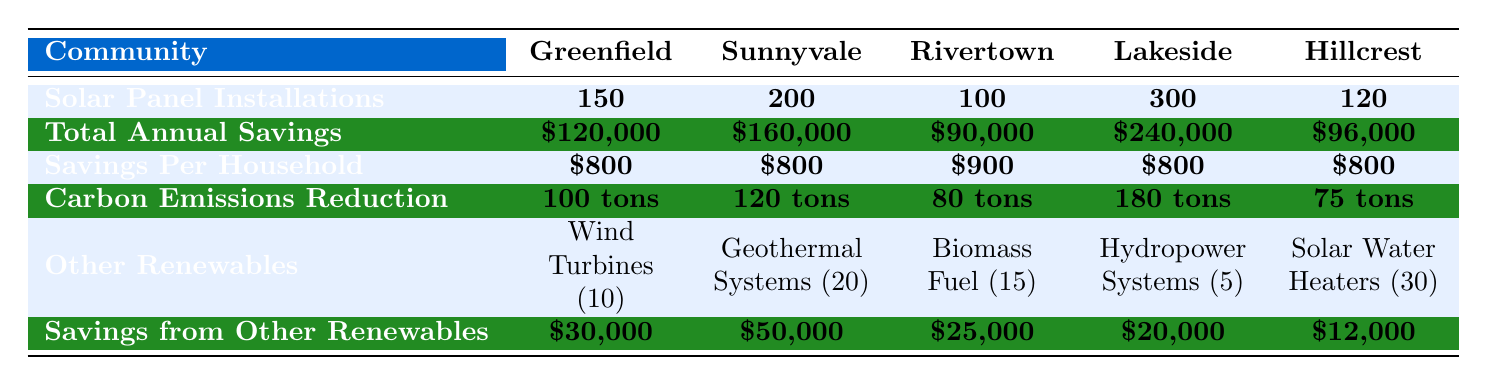What is the total annual savings for Lakeside? In the table, under the "Total Annual Savings" row for Lakeside, the value is listed as \$240,000.
Answer: \$240,000 How many solar panel installations were there in Sunnyvale? In the table, the row for "Solar Panel Installations" shows that Sunnyvale has 200 installations.
Answer: 200 Which community had the highest carbon emissions reduction? By comparing the "Carbon Emissions Reduction" values for each community, Lakeside has the highest at 180 tons.
Answer: Lakeside What is the average savings per household across all communities? The savings per household values are \$800 (Greenfield), \$800 (Sunnyvale), \$900 (Rivertown), \$800 (Lakeside), and \$800 (Hillcrest). Adding them gives \$800 + \$800 + \$900 + \$800 + \$800 = \$4100. Dividing by 5 communities gives \$4100 / 5 = \$820.
Answer: \$820 How much less total annual savings does Rivertown have compared to Lakeside? Rivertown has \$90,000 in total annual savings, while Lakeside has \$240,000. The difference is \$240,000 - \$90,000 = \$150,000.
Answer: \$150,000 Is it true that Hillcrest has more solar panel installations than both Greenfield and Rivertown? Hillcrest has 120 installations, while Greenfield has 150 and Rivertown has 100. Since 120 is not more than 150, the statement is false.
Answer: False What is the combined annual savings from other renewables in Greenfield and Rivertown? Greenfield has \$30,000 and Rivertown has \$25,000 from other renewables. Adding these gives \$30,000 + \$25,000 = \$55,000.
Answer: \$55,000 Which community has the lowest savings from other renewables? Hillcrest has the lowest savings from other renewables listed as \$12,000, compared to others like Greenfield, Sunnyvale, Rivertown, and Lakeside.
Answer: Hillcrest What is the total number of solar panel installations in the community with the highest total annual savings? Lakeside has the highest total annual savings at \$240,000 and has 300 solar panel installations.
Answer: 300 If Rivertown increases its solar panel installations by 50%, how many installations would it then have? Rivertown currently has 100 solar panel installations. Increasing by 50% means adding 50, resulting in 100 + 50 = 150 installations.
Answer: 150 